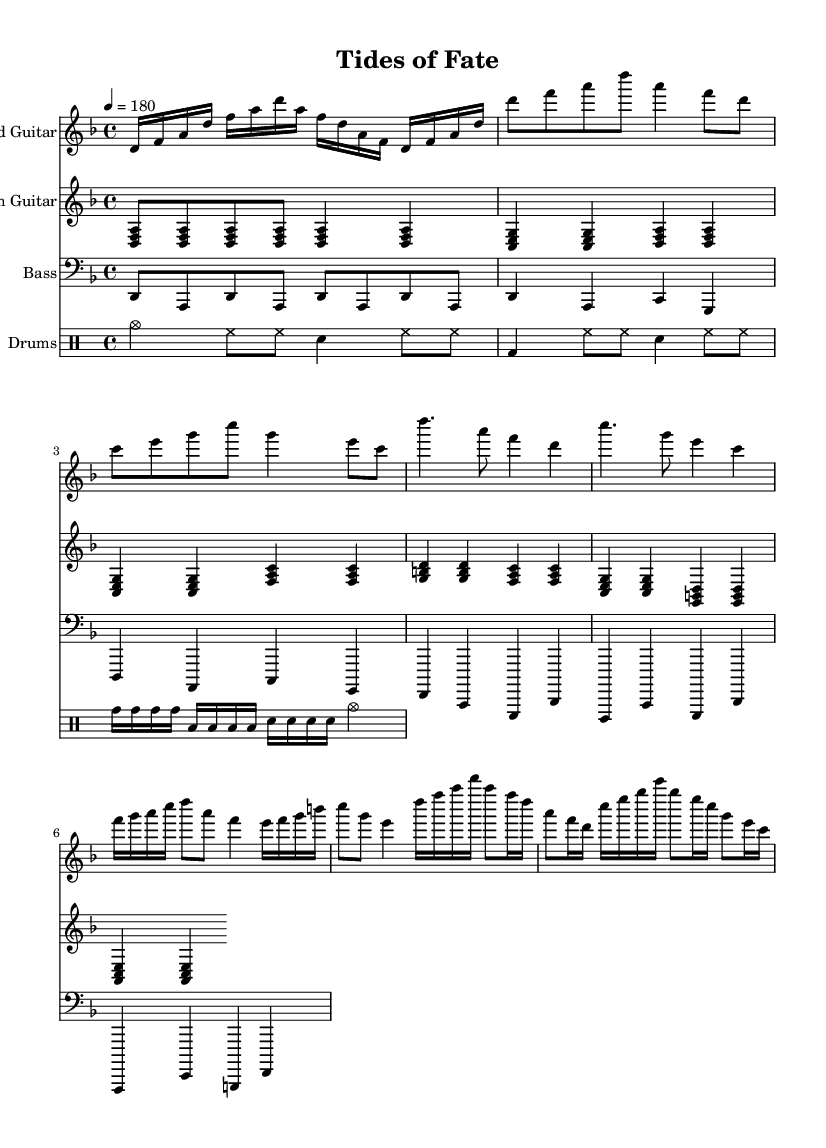What is the key signature of this music? The key signature is indicated by the sharps or flats at the beginning of the staff. In this case, the music is in D minor, which has one flat (B flat).
Answer: D minor What is the time signature of this music? The time signature is found at the beginning of the score and tells us the number of beats in each measure. Here, the time signature is 4/4, meaning there are four beats per measure.
Answer: 4/4 What is the tempo marking for this piece? The tempo marking is usually found above the staff and indicates the speed of the music. This score shows a tempo of 180 beats per minute.
Answer: 180 What is the instrument playing the melody in the intro? The melody in the intro is represented in the lead guitar staff, which is the first staff in the score. The lead guitar plays the main melodic lines throughout the piece.
Answer: Lead Guitar How many measures are in the chorus section? To determine the number of measures in the chorus section, we can count the measures specifically highlighted in the section labeled as "Chorus." In this score, the Chorus has four measures.
Answer: 4 What is unique about the rhythmic pattern used in the drums part? The rhythmic pattern in the drums part features a combination of standard drum sounds like cymbals (cymc), hi-hats (hh), snare (sn), and bass drum (bd), but also includes fills using toms (tomh, toml) which add variety and complexity typical of metal music.
Answer: Features tom fills What variation is found in the bass guitar compared to the rhythm guitar during the verse? The bass guitar plays a more straightforward line focusing on the root notes (D, A, C, G), while the rhythm guitar plays chords. This difference emphasizes the bass's role in supporting the harmonic foundation.
Answer: Root notes 